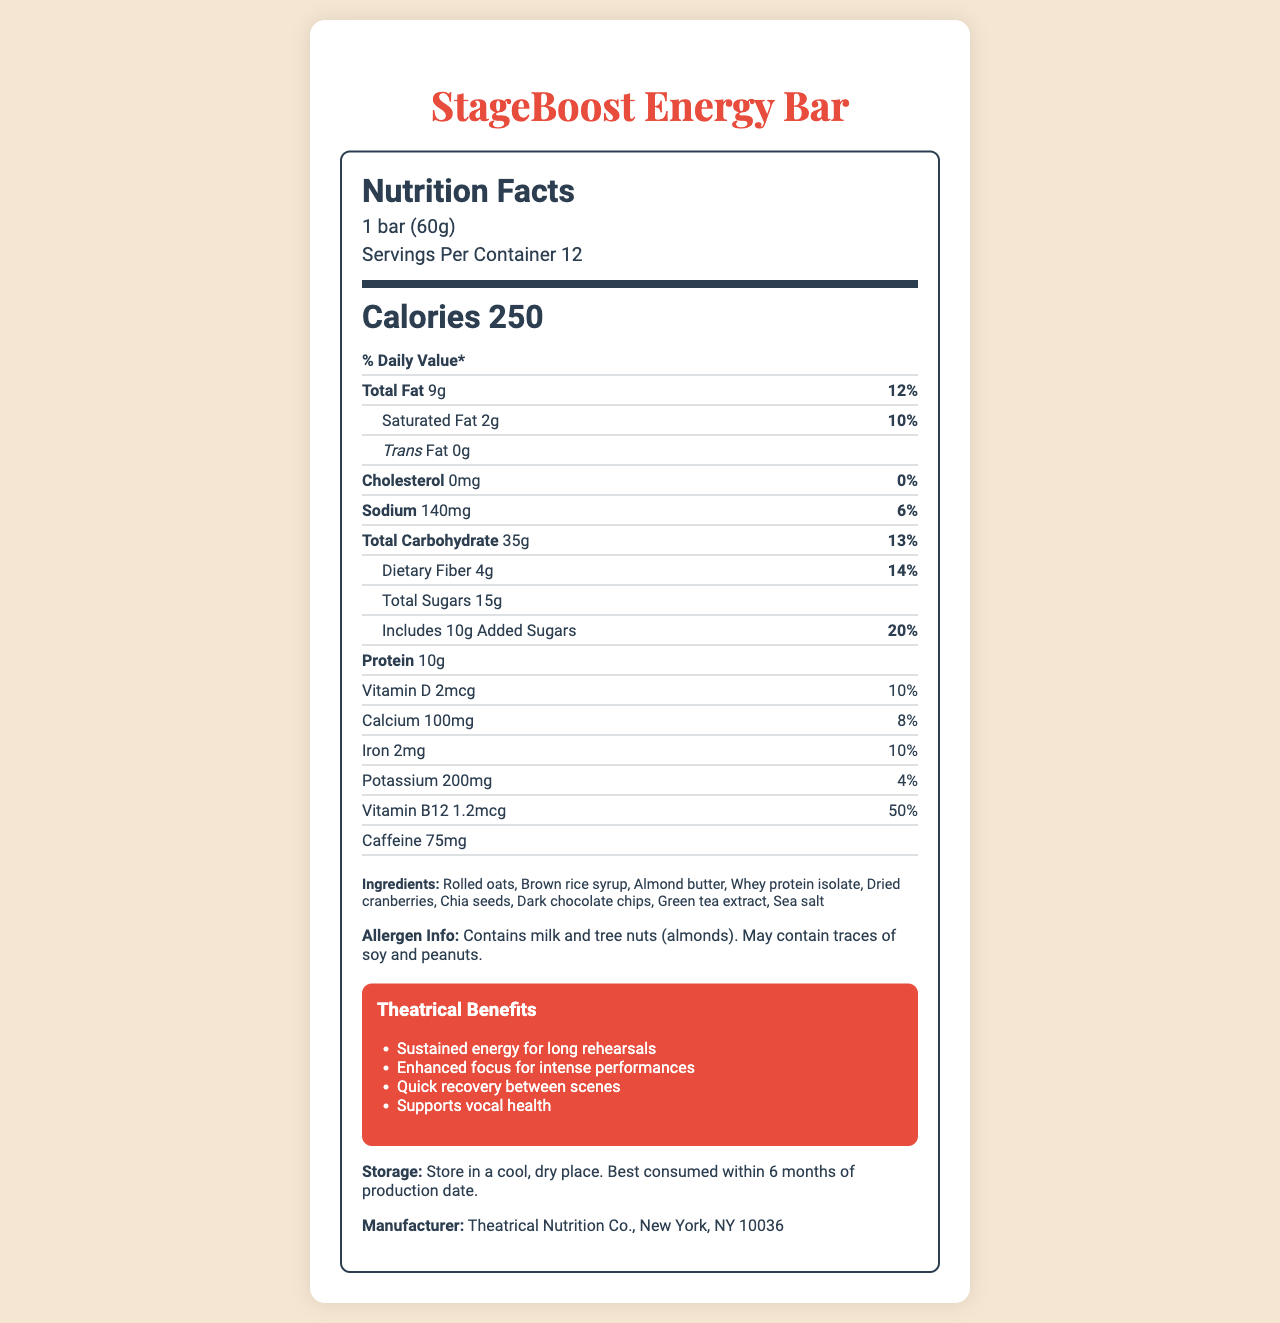what is the serving size of the StageBoost Energy Bar? The serving size is clearly mentioned at the top of the Nutrition Facts section.
Answer: 1 bar (60g) how many calories does one bar contain? The calorie count is listed prominently under the "Calories" label.
Answer: 250 what percentage of the daily value is provided by the total fat content? The total fat content's daily value percentage is mentioned alongside the total fat amount.
Answer: 12% how much sodium is in one serving? The amount of sodium per serving is specified in the nutrient row.
Answer: 140mg what are the two allergens contained in the StageBoost Energy Bar? The allergen information specifies that it contains milk and tree nuts (almonds).
Answer: Milk and tree nuts (almonds) what is the primary benefit of the StageBoost Energy Bar for theater professionals? The first point under "Theatrical Benefits" mentions sustained energy for long rehearsals.
Answer: Sustained energy for long rehearsals which of the following ingredients is NOT in the StageBoost Energy Bar? A. Rolled oats B. Brown rice syrup C. Peanut butter D. Almond butter Peanut butter is not listed in the ingredients; almond butter is mentioned instead.
Answer: C what is the caffeine content in one bar? The caffeine content of one bar is listed under the nutrients.
Answer: 75mg which vitamin covers the highest percent of the daily value? A. Vitamin D B. Calcium C. Iron D. Vitamin B12 Vitamin B12 covers 50% of the daily value, the highest among the listed vitamins and minerals.
Answer: D are there any trans fats in the StageBoost Energy Bar? The label indicates that the trans fat content is 0g.
Answer: No summarize the main idea of the document. The document covers all key aspects related to the nutritional content and benefits of the StageBoost Energy Bar, making it useful for theater professionals seeking a balanced energy boost.
Answer: The document provides detailed nutritional information about the StageBoost Energy Bar, designed specifically for theater professionals to aid in long rehearsals and intense performances. It highlights the product's calories, fat, vitamins, caffeine, and other nutritional values, along with theatrical benefits, ingredients, allergen information, and storage instructions. how many servings are there per container? The number of servings per container is stated right after the serving size information.
Answer: 12 what is the total carbohydrate content per serving, and what is its daily value percentage? The total carbohydrate content is 35g, and the daily value percentage is 13%.
Answer: 35g, 13% list three ingredients found in the StageBoost Energy Bar. Three of the listed ingredients are rolled oats, almond butter, and dark chocolate chips.
Answer: Rolled oats, Almond butter, Dark chocolate chips is there enough information to determine the production date of the energy bar? The document does not provide details about the production date; it only mentions the storage instruction to consume within 6 months of production.
Answer: No how much dietary fiber does one bar contain? The dietary fiber content per serving is listed as 4g.
Answer: 4g how much added sugar is in one StageBoost Energy Bar? The amount of added sugars is specified in the nutrient row.
Answer: 10g 